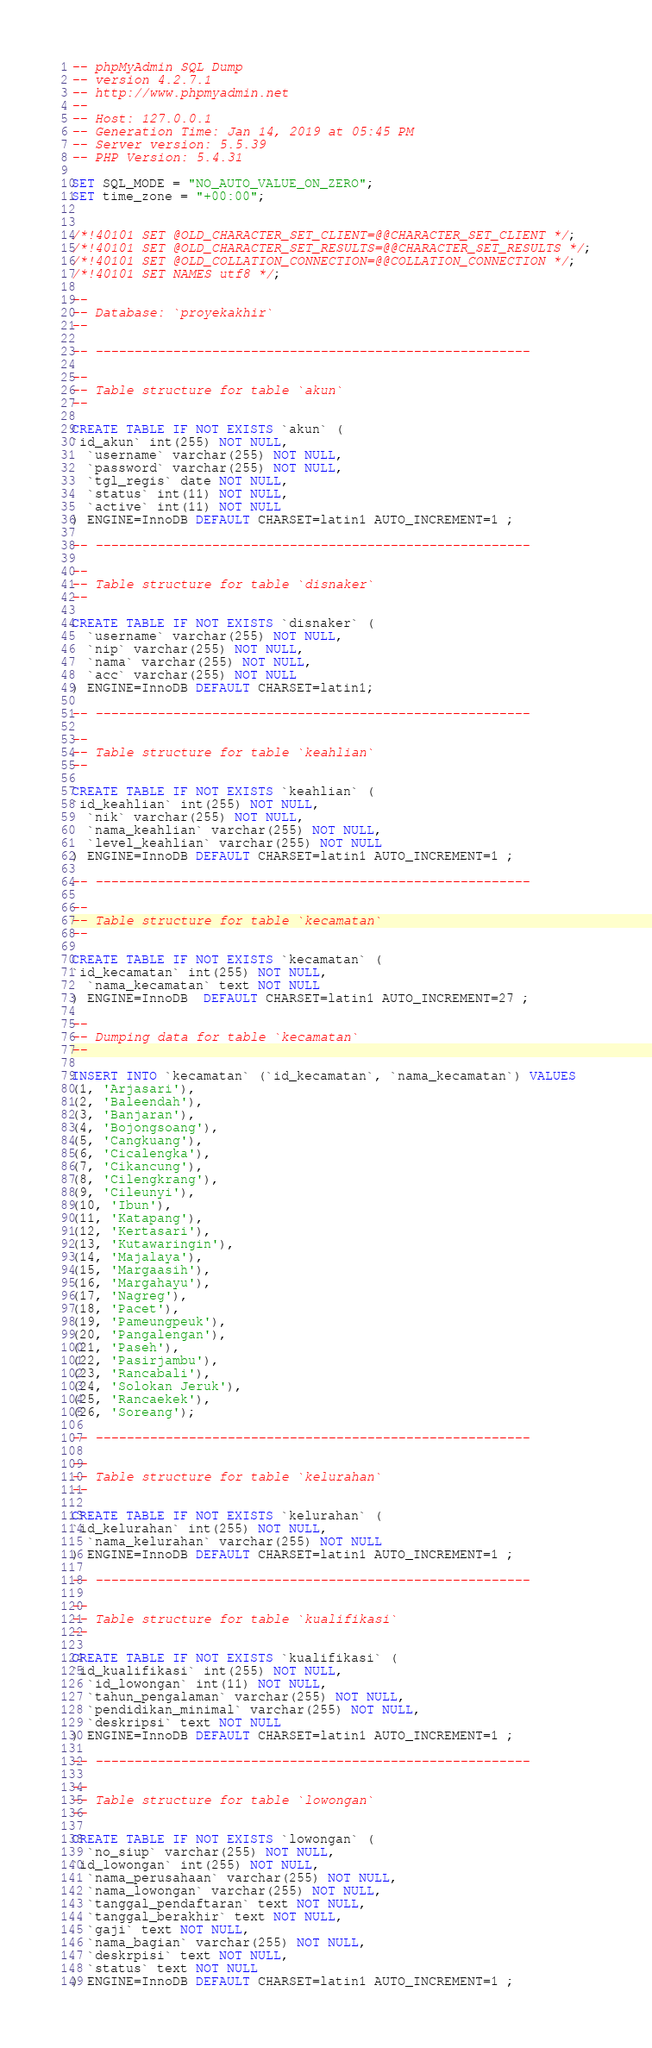Convert code to text. <code><loc_0><loc_0><loc_500><loc_500><_SQL_>-- phpMyAdmin SQL Dump
-- version 4.2.7.1
-- http://www.phpmyadmin.net
--
-- Host: 127.0.0.1
-- Generation Time: Jan 14, 2019 at 05:45 PM
-- Server version: 5.5.39
-- PHP Version: 5.4.31

SET SQL_MODE = "NO_AUTO_VALUE_ON_ZERO";
SET time_zone = "+00:00";


/*!40101 SET @OLD_CHARACTER_SET_CLIENT=@@CHARACTER_SET_CLIENT */;
/*!40101 SET @OLD_CHARACTER_SET_RESULTS=@@CHARACTER_SET_RESULTS */;
/*!40101 SET @OLD_COLLATION_CONNECTION=@@COLLATION_CONNECTION */;
/*!40101 SET NAMES utf8 */;

--
-- Database: `proyekakhir`
--

-- --------------------------------------------------------

--
-- Table structure for table `akun`
--

CREATE TABLE IF NOT EXISTS `akun` (
`id_akun` int(255) NOT NULL,
  `username` varchar(255) NOT NULL,
  `password` varchar(255) NOT NULL,
  `tgl_regis` date NOT NULL,
  `status` int(11) NOT NULL,
  `active` int(11) NOT NULL
) ENGINE=InnoDB DEFAULT CHARSET=latin1 AUTO_INCREMENT=1 ;

-- --------------------------------------------------------

--
-- Table structure for table `disnaker`
--

CREATE TABLE IF NOT EXISTS `disnaker` (
  `username` varchar(255) NOT NULL,
  `nip` varchar(255) NOT NULL,
  `nama` varchar(255) NOT NULL,
  `acc` varchar(255) NOT NULL
) ENGINE=InnoDB DEFAULT CHARSET=latin1;

-- --------------------------------------------------------

--
-- Table structure for table `keahlian`
--

CREATE TABLE IF NOT EXISTS `keahlian` (
`id_keahlian` int(255) NOT NULL,
  `nik` varchar(255) NOT NULL,
  `nama_keahlian` varchar(255) NOT NULL,
  `level_keahlian` varchar(255) NOT NULL
) ENGINE=InnoDB DEFAULT CHARSET=latin1 AUTO_INCREMENT=1 ;

-- --------------------------------------------------------

--
-- Table structure for table `kecamatan`
--

CREATE TABLE IF NOT EXISTS `kecamatan` (
`id_kecamatan` int(255) NOT NULL,
  `nama_kecamatan` text NOT NULL
) ENGINE=InnoDB  DEFAULT CHARSET=latin1 AUTO_INCREMENT=27 ;

--
-- Dumping data for table `kecamatan`
--

INSERT INTO `kecamatan` (`id_kecamatan`, `nama_kecamatan`) VALUES
(1, 'Arjasari'),
(2, 'Baleendah'),
(3, 'Banjaran'),
(4, 'Bojongsoang'),
(5, 'Cangkuang'),
(6, 'Cicalengka'),
(7, 'Cikancung'),
(8, 'Cilengkrang'),
(9, 'Cileunyi'),
(10, 'Ibun'),
(11, 'Katapang'),
(12, 'Kertasari'),
(13, 'Kutawaringin'),
(14, 'Majalaya'),
(15, 'Margaasih'),
(16, 'Margahayu'),
(17, 'Nagreg'),
(18, 'Pacet'),
(19, 'Pameungpeuk'),
(20, 'Pangalengan'),
(21, 'Paseh'),
(22, 'Pasirjambu'),
(23, 'Rancabali'),
(24, 'Solokan Jeruk'),
(25, 'Rancaekek'),
(26, 'Soreang');

-- --------------------------------------------------------

--
-- Table structure for table `kelurahan`
--

CREATE TABLE IF NOT EXISTS `kelurahan` (
`id_kelurahan` int(255) NOT NULL,
  `nama_kelurahan` varchar(255) NOT NULL
) ENGINE=InnoDB DEFAULT CHARSET=latin1 AUTO_INCREMENT=1 ;

-- --------------------------------------------------------

--
-- Table structure for table `kualifikasi`
--

CREATE TABLE IF NOT EXISTS `kualifikasi` (
`id_kualifikasi` int(255) NOT NULL,
  `id_lowongan` int(11) NOT NULL,
  `tahun_pengalaman` varchar(255) NOT NULL,
  `pendidikan_minimal` varchar(255) NOT NULL,
  `deskripsi` text NOT NULL
) ENGINE=InnoDB DEFAULT CHARSET=latin1 AUTO_INCREMENT=1 ;

-- --------------------------------------------------------

--
-- Table structure for table `lowongan`
--

CREATE TABLE IF NOT EXISTS `lowongan` (
  `no_siup` varchar(255) NOT NULL,
`id_lowongan` int(255) NOT NULL,
  `nama_perusahaan` varchar(255) NOT NULL,
  `nama_lowongan` varchar(255) NOT NULL,
  `tanggal_pendaftaran` text NOT NULL,
  `tanggal_berakhir` text NOT NULL,
  `gaji` text NOT NULL,
  `nama_bagian` varchar(255) NOT NULL,
  `deskrpisi` text NOT NULL,
  `status` text NOT NULL
) ENGINE=InnoDB DEFAULT CHARSET=latin1 AUTO_INCREMENT=1 ;
</code> 